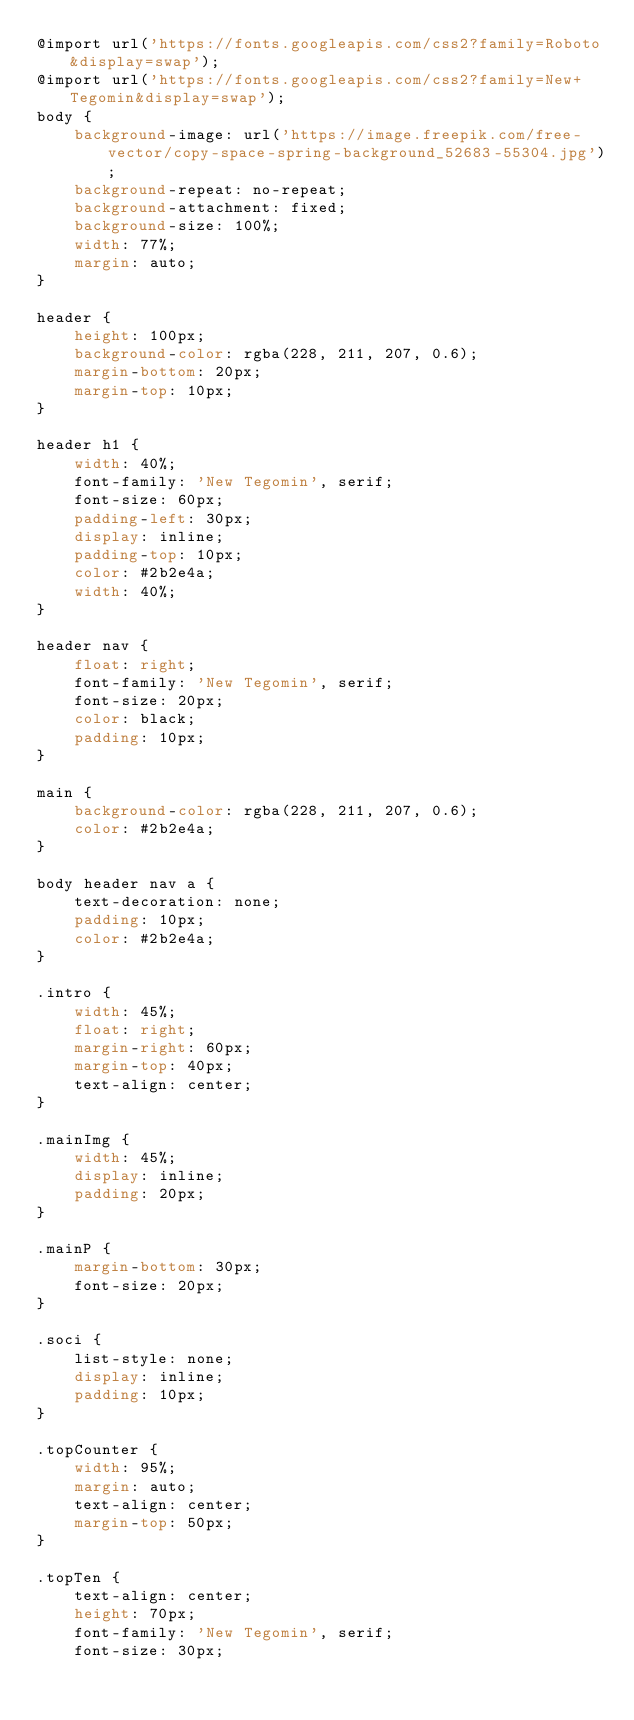Convert code to text. <code><loc_0><loc_0><loc_500><loc_500><_CSS_>@import url('https://fonts.googleapis.com/css2?family=Roboto&display=swap');
@import url('https://fonts.googleapis.com/css2?family=New+Tegomin&display=swap');
body {
    background-image: url('https://image.freepik.com/free-vector/copy-space-spring-background_52683-55304.jpg');
    background-repeat: no-repeat;
    background-attachment: fixed;
    background-size: 100%;
    width: 77%;
    margin: auto;
}

header {
    height: 100px;
    background-color: rgba(228, 211, 207, 0.6);
    margin-bottom: 20px;
    margin-top: 10px;
}

header h1 {
    width: 40%;
    font-family: 'New Tegomin', serif;
    font-size: 60px;
    padding-left: 30px;
    display: inline;
    padding-top: 10px;
    color: #2b2e4a;
    width: 40%;
}

header nav {
    float: right;
    font-family: 'New Tegomin', serif;
    font-size: 20px;
    color: black;
    padding: 10px;
}

main {
    background-color: rgba(228, 211, 207, 0.6);
    color: #2b2e4a;
}

body header nav a {
    text-decoration: none;
    padding: 10px;
    color: #2b2e4a;
}

.intro {
    width: 45%;
    float: right;
    margin-right: 60px;
    margin-top: 40px;
    text-align: center;
}

.mainImg {
    width: 45%;
    display: inline;
    padding: 20px;
}

.mainP {
    margin-bottom: 30px;
    font-size: 20px;
}

.soci {
    list-style: none;
    display: inline;
    padding: 10px;
}

.topCounter {
    width: 95%;
    margin: auto;
    text-align: center;
    margin-top: 50px;
}

.topTen {
    text-align: center;
    height: 70px;
    font-family: 'New Tegomin', serif;
    font-size: 30px;</code> 